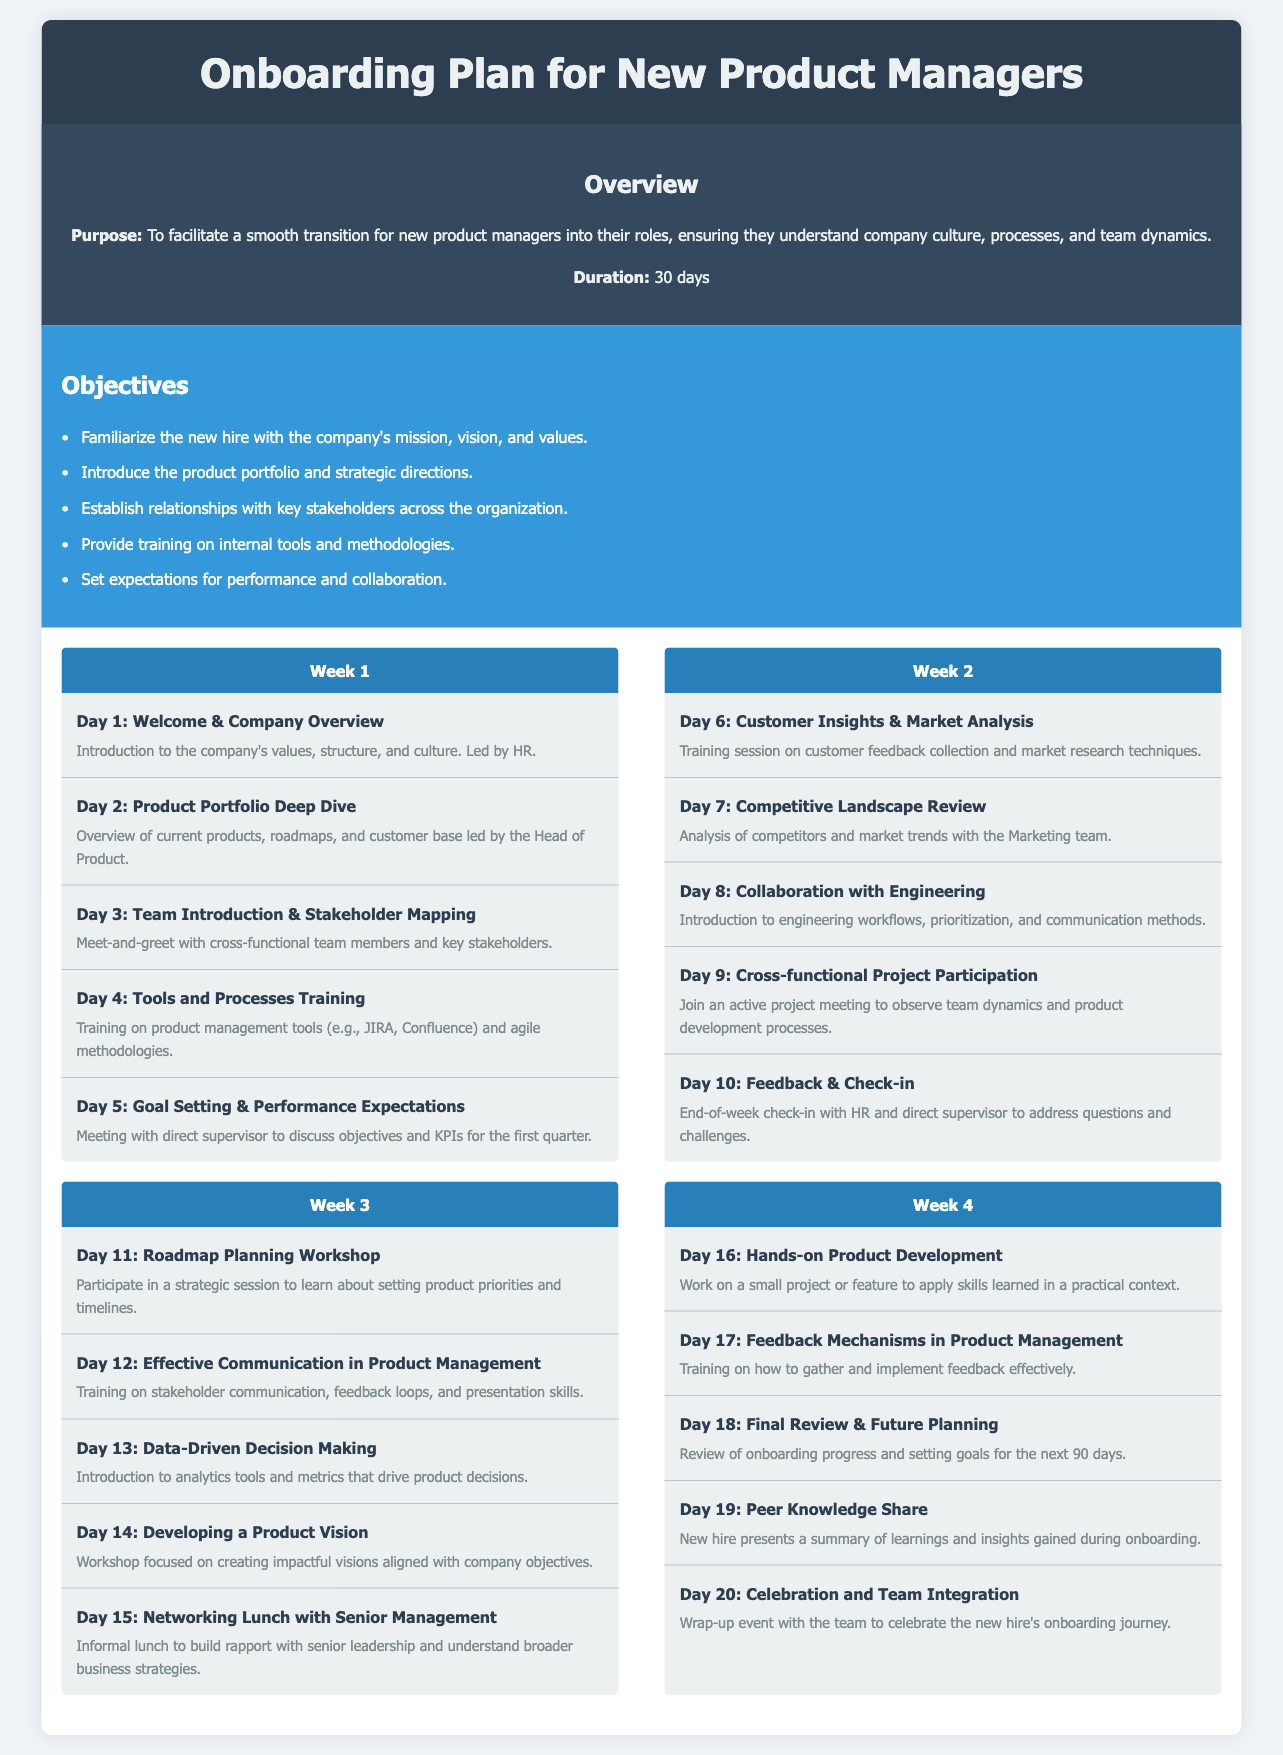What is the duration of the onboarding plan? The document states that the duration of the onboarding plan is 30 days.
Answer: 30 days Who leads the Day 1 welcome session? The introduction to the company's values, structure, and culture is led by HR on Day 1.
Answer: HR What training is provided on Day 4? Day 4 includes training on product management tools and agile methodologies.
Answer: Tools and Processes Training How many weeks are in the onboarding plan? The onboarding plan is structured into four weeks.
Answer: Four weeks What is the objective of establishing relationships with key stakeholders? One of the objectives is to establish relationships with stakeholders across the organization.
Answer: Establish relationships with key stakeholders Which day focuses on customer insights? Day 6 is dedicated to customer insights and market analysis training.
Answer: Day 6 Who participates in the networking lunch on Day 15? The networking lunch on Day 15 is with senior management.
Answer: Senior management What session occurs on Day 18? Day 18 is focused on the final review and future planning.
Answer: Final Review & Future Planning What theme is emphasized during the last day of the onboarding process? The last day emphasizes celebration and team integration.
Answer: Celebration and Team Integration 